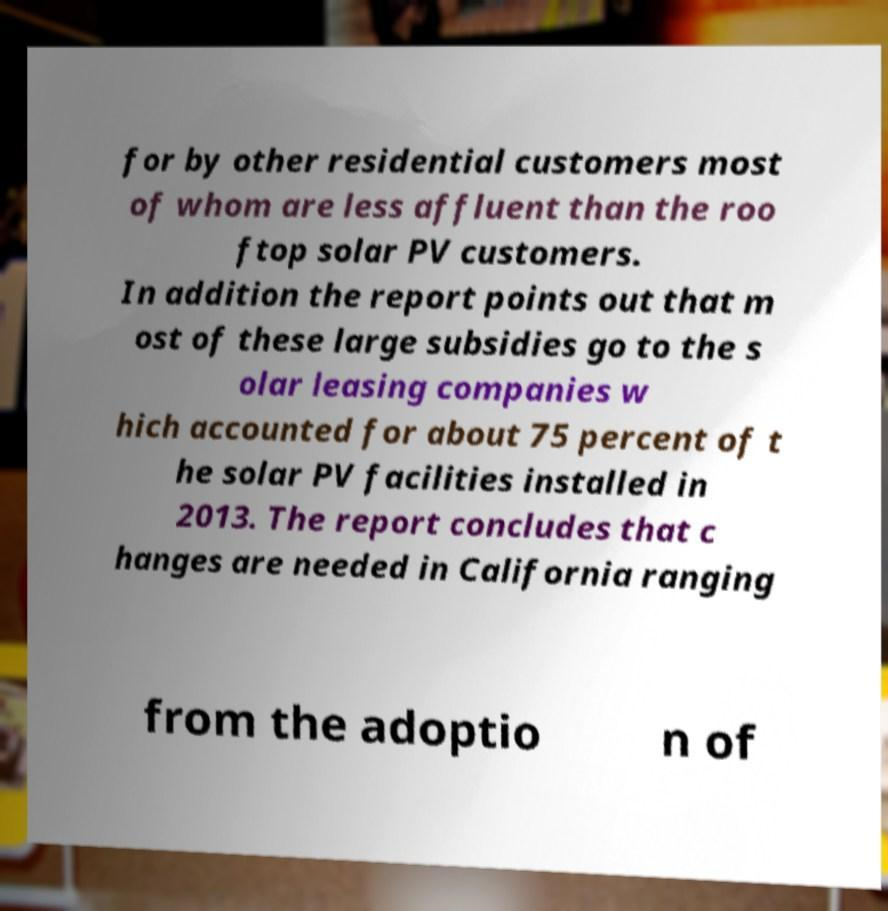Please identify and transcribe the text found in this image. for by other residential customers most of whom are less affluent than the roo ftop solar PV customers. In addition the report points out that m ost of these large subsidies go to the s olar leasing companies w hich accounted for about 75 percent of t he solar PV facilities installed in 2013. The report concludes that c hanges are needed in California ranging from the adoptio n of 